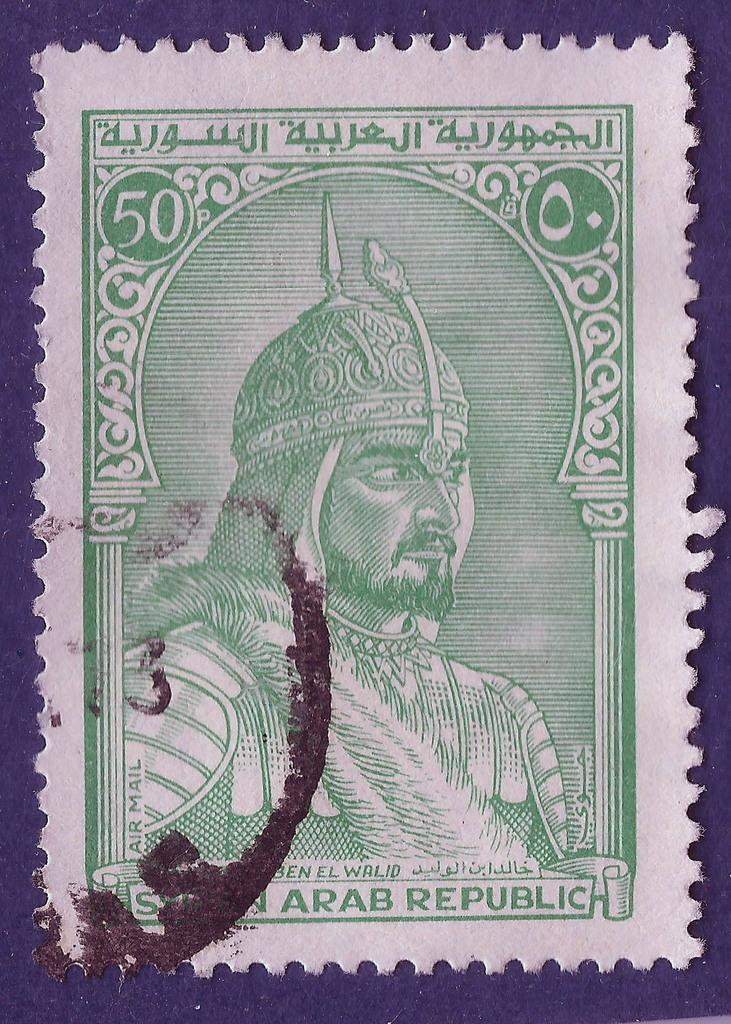What is the main subject of the image? The main subject of the image is a postage stamp. Can you describe the person featured on the postage stamp? The postage stamp features a person. What else can be seen on the postage stamp besides the person? There is writing on the postage stamp. What type of pickle is being used to hold the postage stamp in the image? There is no pickle present in the image; the postage stamp is not being held by any object. What type of laborer is depicted on the postage stamp? The provided facts do not mention the occupation or type of laborer depicted on the postage stamp. 